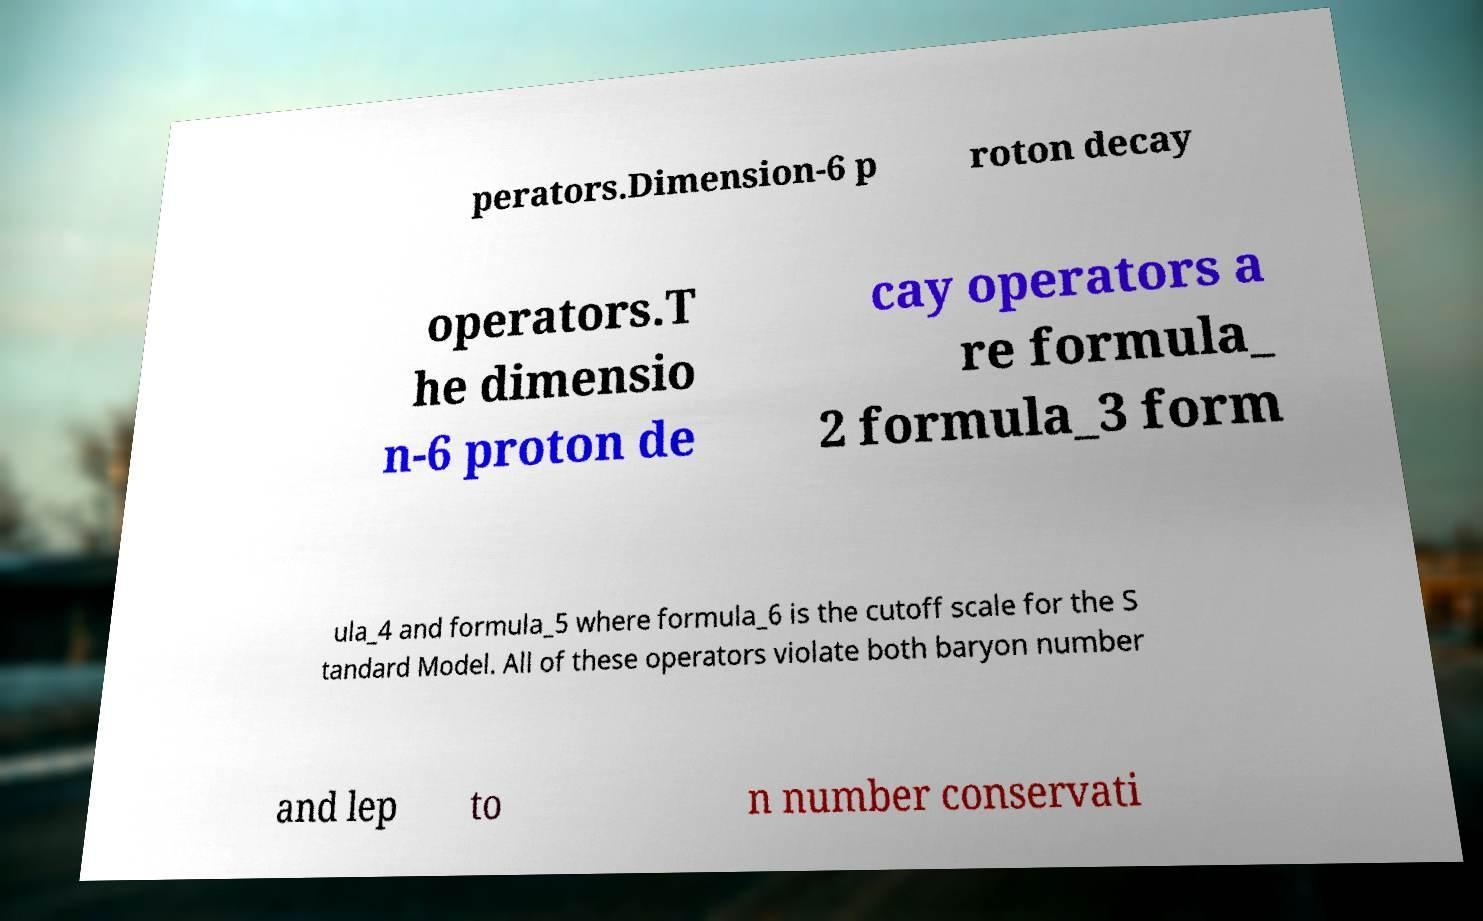There's text embedded in this image that I need extracted. Can you transcribe it verbatim? perators.Dimension-6 p roton decay operators.T he dimensio n-6 proton de cay operators a re formula_ 2 formula_3 form ula_4 and formula_5 where formula_6 is the cutoff scale for the S tandard Model. All of these operators violate both baryon number and lep to n number conservati 